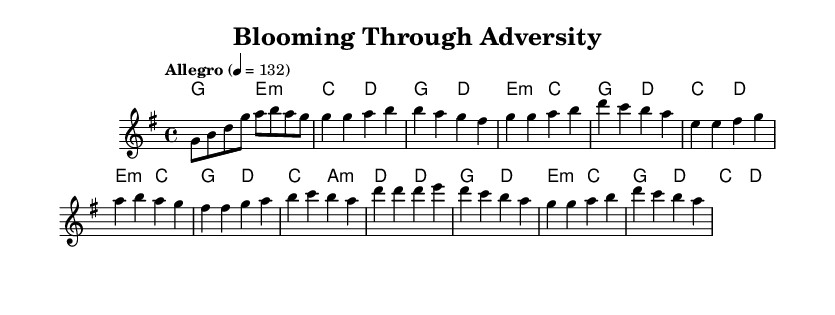What is the key signature of this music? The key signature is G major, which has one sharp (F#).
Answer: G major What is the time signature of this music? The time signature is 4/4, meaning there are four beats per measure.
Answer: 4/4 What is the tempo marking for this piece? The tempo marking is "Allegro," indicating a fast pace, specifically set at 132 beats per minute.
Answer: Allegro How many sections does the song have? The song has three main sections: Verse, Pre-Chorus, and Chorus.
Answer: Three In which part does the lyrics mention "stronger than these symptoms"? This lyric appears in the Pre-Chorus section, emphasizing resilience in overcoming challenges.
Answer: Pre-Chorus What does the chorus emphasize about the attitude towards health challenges? The chorus emphasizes positivity and determination to thrive despite difficulties, highlighting growth and resilience.
Answer: Blooming, thriving What chord is used in the Intro? The chord used in the Intro is G major, followed by E minor and C major.
Answer: G major 